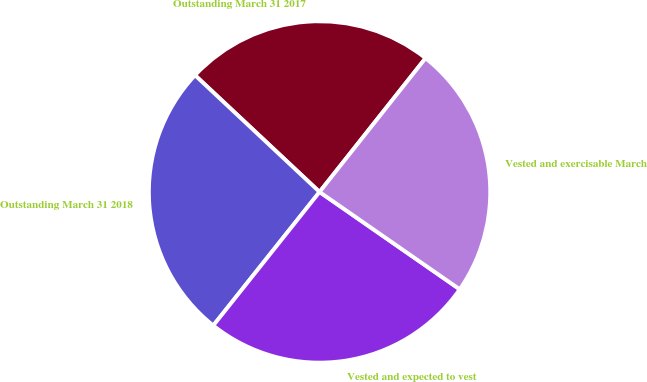Convert chart. <chart><loc_0><loc_0><loc_500><loc_500><pie_chart><fcel>Outstanding March 31 2017<fcel>Outstanding March 31 2018<fcel>Vested and expected to vest<fcel>Vested and exercisable March<nl><fcel>23.68%<fcel>26.29%<fcel>26.04%<fcel>24.0%<nl></chart> 